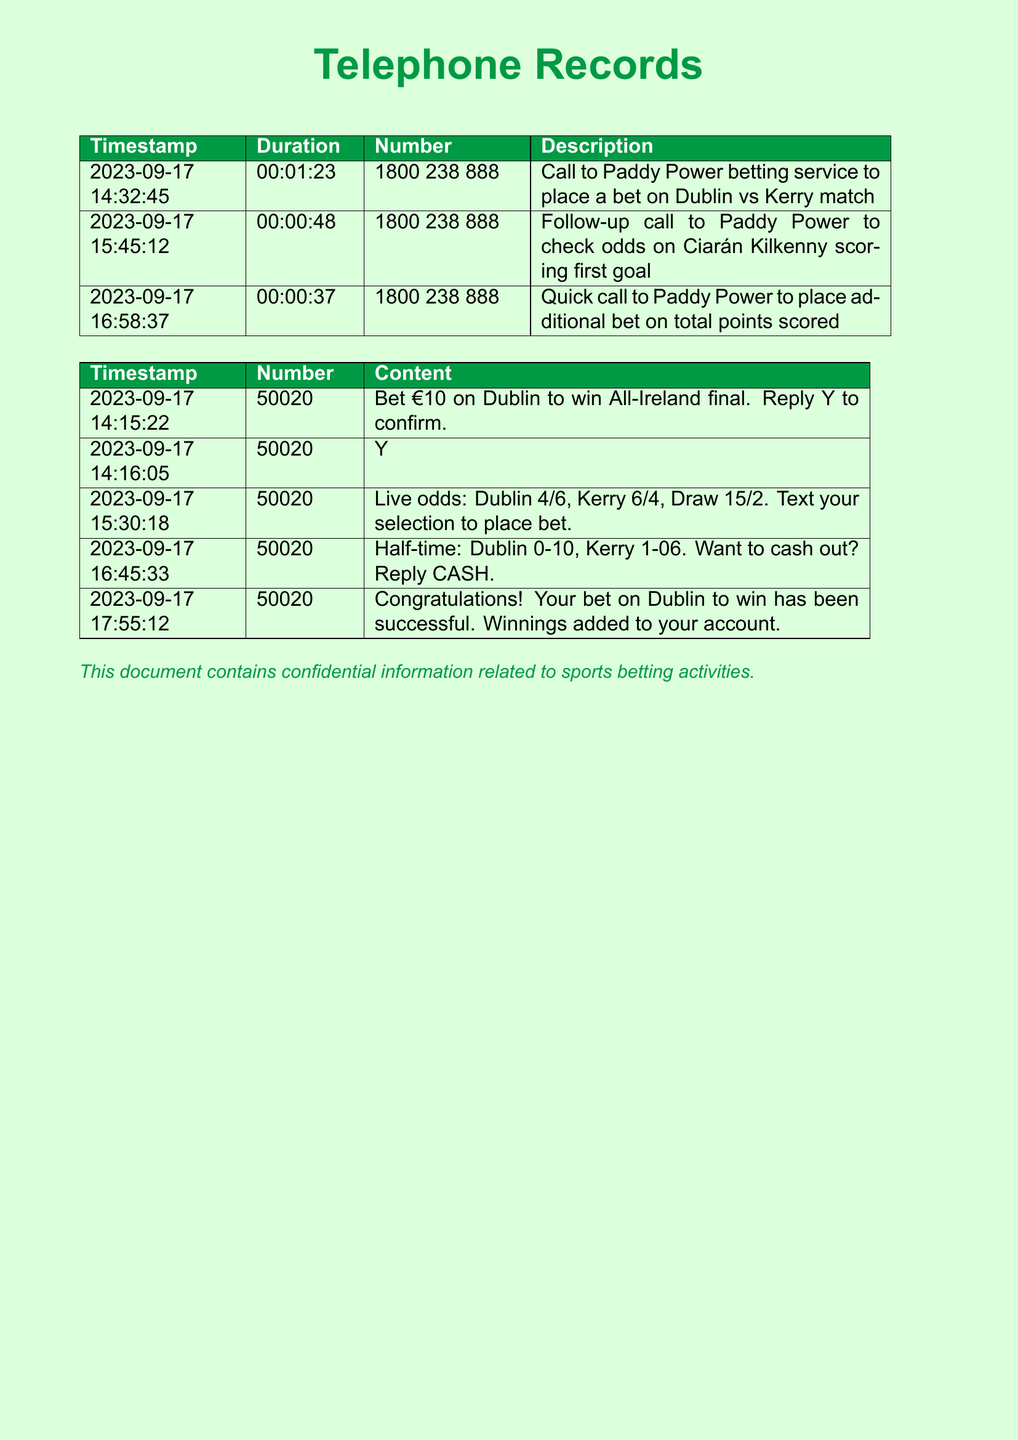what is the first call time? The first call time is the timestamp of the earliest call made in the records. The first call was made at 14:32:45.
Answer: 14:32:45 how long was the follow-up call? The follow-up call duration is provided in the document as the time spent on the call. The duration of the follow-up call is 00:00:48.
Answer: 00:00:48 which betting service was contacted? The document specifies the name of the betting service used for all calls. The service contacted is Paddy Power.
Answer: Paddy Power what did the text sent at 14:15:22 request? The text sent at 14:15:22 is asking for a specific bet to be placed. The request was to bet €10 on Dublin to win All-Ireland final.
Answer: Bet €10 on Dublin to win All-Ireland final what was the half-time score? The half-time score is a relevant piece of information from the text sent at 16:45:33. The score was Dublin 0-10, Kerry 1-06.
Answer: Dublin 0-10, Kerry 1-06 which player was mentioned for scoring odds? The document contains a reference to a specific player associated with scoring. The player mentioned is Ciarán Kilkenny.
Answer: Ciarán Kilkenny how many calls were made to the betting service? The total number of calls made can be determined by counting the entries in the call records. A total of three calls were made to the betting service.
Answer: 3 what is the final outcome of the bet? The outcome of the bet is communicated in the last text message sent at 17:55:12. The final outcome was successful for the bet on Dublin to win.
Answer: Successful what is the response rate for confirming a bet? The document indicates the confirmation method for a bet via text. Responding with 'Y' confirms the bet.
Answer: Y 